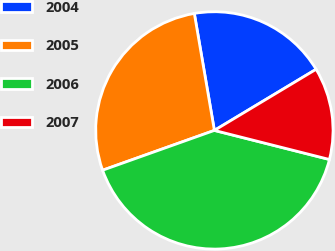<chart> <loc_0><loc_0><loc_500><loc_500><pie_chart><fcel>2004<fcel>2005<fcel>2006<fcel>2007<nl><fcel>19.09%<fcel>27.74%<fcel>40.61%<fcel>12.55%<nl></chart> 